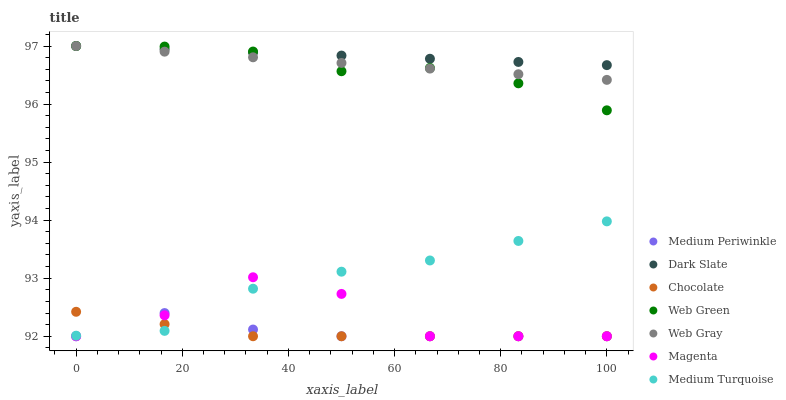Does Chocolate have the minimum area under the curve?
Answer yes or no. Yes. Does Dark Slate have the maximum area under the curve?
Answer yes or no. Yes. Does Medium Periwinkle have the minimum area under the curve?
Answer yes or no. No. Does Medium Periwinkle have the maximum area under the curve?
Answer yes or no. No. Is Dark Slate the smoothest?
Answer yes or no. Yes. Is Magenta the roughest?
Answer yes or no. Yes. Is Medium Periwinkle the smoothest?
Answer yes or no. No. Is Medium Periwinkle the roughest?
Answer yes or no. No. Does Medium Periwinkle have the lowest value?
Answer yes or no. Yes. Does Web Green have the lowest value?
Answer yes or no. No. Does Dark Slate have the highest value?
Answer yes or no. Yes. Does Medium Periwinkle have the highest value?
Answer yes or no. No. Is Magenta less than Web Gray?
Answer yes or no. Yes. Is Web Green greater than Chocolate?
Answer yes or no. Yes. Does Web Gray intersect Web Green?
Answer yes or no. Yes. Is Web Gray less than Web Green?
Answer yes or no. No. Is Web Gray greater than Web Green?
Answer yes or no. No. Does Magenta intersect Web Gray?
Answer yes or no. No. 